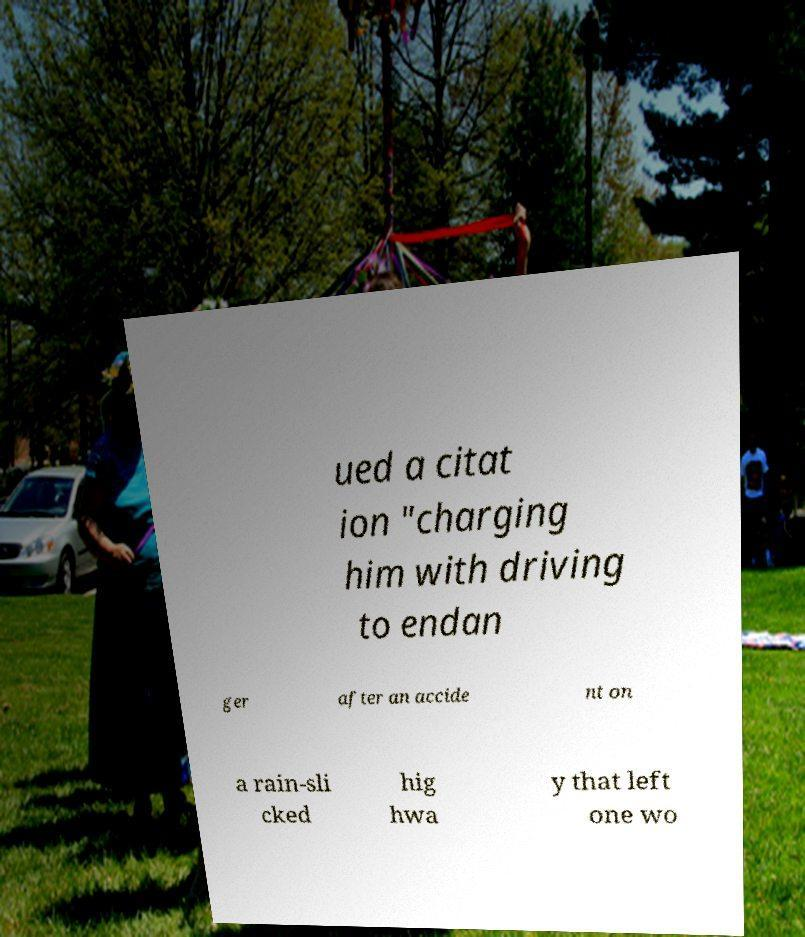Could you assist in decoding the text presented in this image and type it out clearly? ued a citat ion "charging him with driving to endan ger after an accide nt on a rain-sli cked hig hwa y that left one wo 